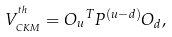Convert formula to latex. <formula><loc_0><loc_0><loc_500><loc_500>V _ { _ { C K M } } ^ { ^ { t h } } = { O _ { u } } ^ { T } P ^ { ( u - d ) } { O } _ { d } ,</formula> 